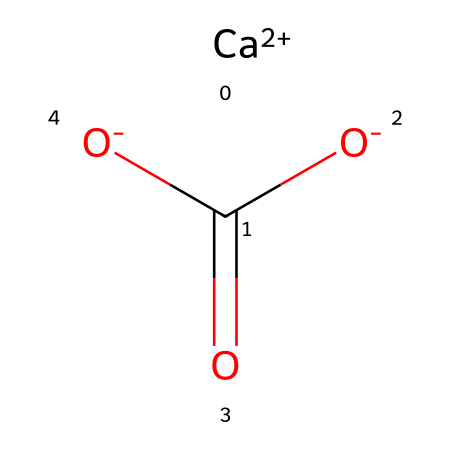What is the primary metal present in this chemical? The chemical structure contains a calcium ion, indicated by "Ca" in the SMILES representation. Calcium is a primary component in limestone.
Answer: calcium How many oxygen atoms are in this chemical? By analyzing the SMILES representation, there are three oxygen atoms present, associated with the carbonate ion structure in limestone.
Answer: 3 What type of compound is represented by this chemical structure? The presence of calcium ions and carbonate ions indicates that this chemical represents a salt, specifically calcium carbonate, which is typical for limestone.
Answer: salt What is the charge of the calcium ion in this chemical? The representation shows "Ca+2," indicating that the calcium ion has a +2 charge, which is typical for calcium in compounds.
Answer: +2 How many double bonds are present in the chemical structure? The chemical structure includes one double bond (between carbon and one of the oxygen atoms), suggesting a carboxylate structure in calcium carbonate.
Answer: 1 What is the empirical formula derived from this chemical structure? From the elements present (one calcium atom, one carbon atom, and three oxygen atoms), the empirical formula can be deduced as CaCO3, representing calcium carbonate.
Answer: CaCO3 